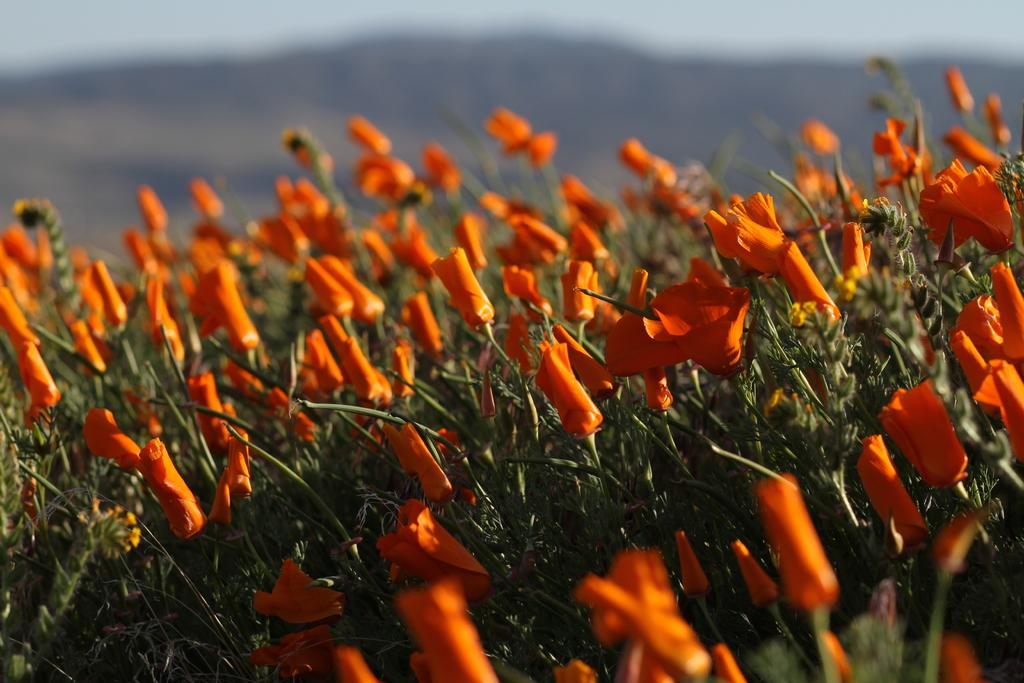What type of plants are visible in the image? There are plants with flowers in the image. Can you describe the background of the image? The background of the image is blurred. What type of store can be seen in the background of the image? There is no store visible in the image; the background is blurred. What thrilling activity is taking place in the image? There is no thrilling activity present in the image; it features plants with flowers and a blurred background. 